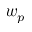<formula> <loc_0><loc_0><loc_500><loc_500>w _ { p }</formula> 